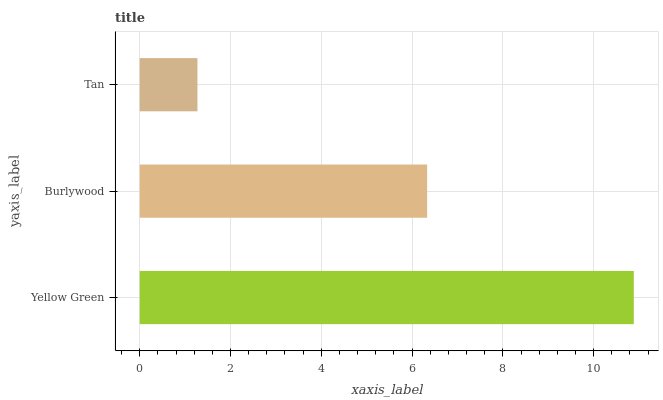Is Tan the minimum?
Answer yes or no. Yes. Is Yellow Green the maximum?
Answer yes or no. Yes. Is Burlywood the minimum?
Answer yes or no. No. Is Burlywood the maximum?
Answer yes or no. No. Is Yellow Green greater than Burlywood?
Answer yes or no. Yes. Is Burlywood less than Yellow Green?
Answer yes or no. Yes. Is Burlywood greater than Yellow Green?
Answer yes or no. No. Is Yellow Green less than Burlywood?
Answer yes or no. No. Is Burlywood the high median?
Answer yes or no. Yes. Is Burlywood the low median?
Answer yes or no. Yes. Is Yellow Green the high median?
Answer yes or no. No. Is Tan the low median?
Answer yes or no. No. 